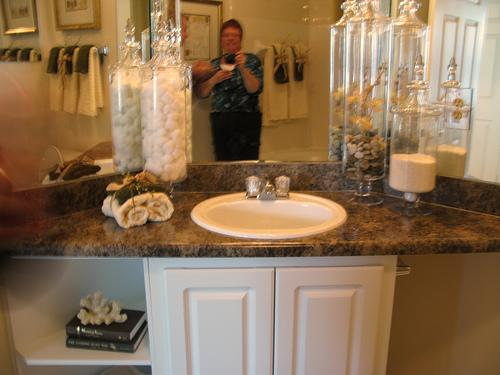What material are the white rounds in the jar made of? Please explain your reasoning. cotton. Cottons balls are made of cotton. 